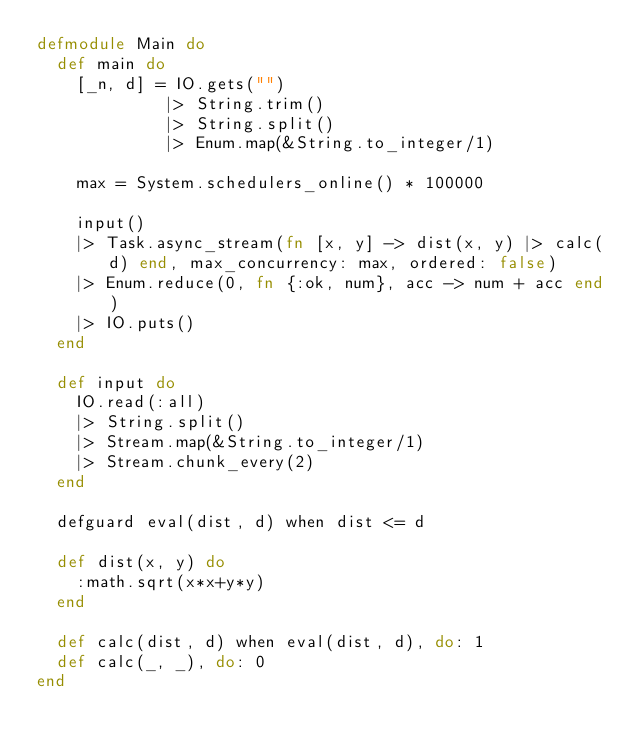Convert code to text. <code><loc_0><loc_0><loc_500><loc_500><_Elixir_>defmodule Main do
  def main do
    [_n, d] = IO.gets("")
             |> String.trim()
             |> String.split()
             |> Enum.map(&String.to_integer/1)

    max = System.schedulers_online() * 100000

    input()
    |> Task.async_stream(fn [x, y] -> dist(x, y) |> calc(d) end, max_concurrency: max, ordered: false)
    |> Enum.reduce(0, fn {:ok, num}, acc -> num + acc end)
    |> IO.puts()
  end

  def input do
    IO.read(:all)
    |> String.split()
    |> Stream.map(&String.to_integer/1)
    |> Stream.chunk_every(2)
  end

  defguard eval(dist, d) when dist <= d

  def dist(x, y) do
    :math.sqrt(x*x+y*y)
  end

  def calc(dist, d) when eval(dist, d), do: 1
  def calc(_, _), do: 0
end
</code> 